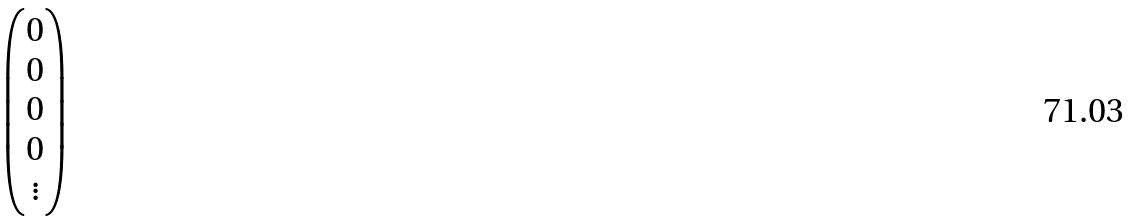<formula> <loc_0><loc_0><loc_500><loc_500>\begin{pmatrix} 0 \\ 0 \\ 0 \\ 0 \\ \vdots \end{pmatrix}</formula> 